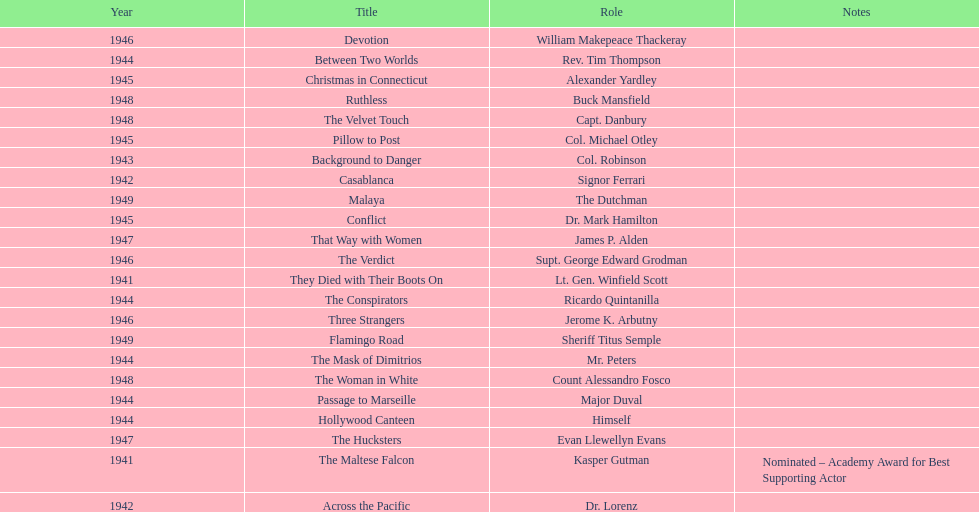How many movies has he been from 1941-1949. 23. 